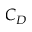Convert formula to latex. <formula><loc_0><loc_0><loc_500><loc_500>C _ { D }</formula> 